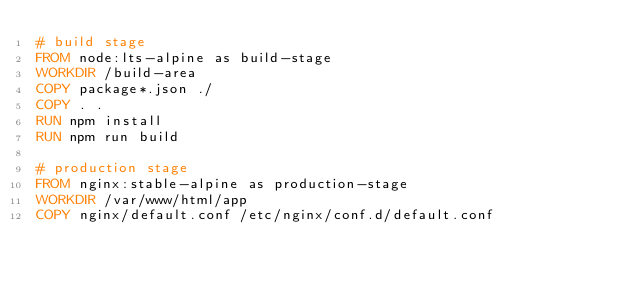<code> <loc_0><loc_0><loc_500><loc_500><_Dockerfile_># build stage
FROM node:lts-alpine as build-stage
WORKDIR /build-area
COPY package*.json ./
COPY . .
RUN npm install
RUN npm run build

# production stage
FROM nginx:stable-alpine as production-stage
WORKDIR /var/www/html/app
COPY nginx/default.conf /etc/nginx/conf.d/default.conf</code> 